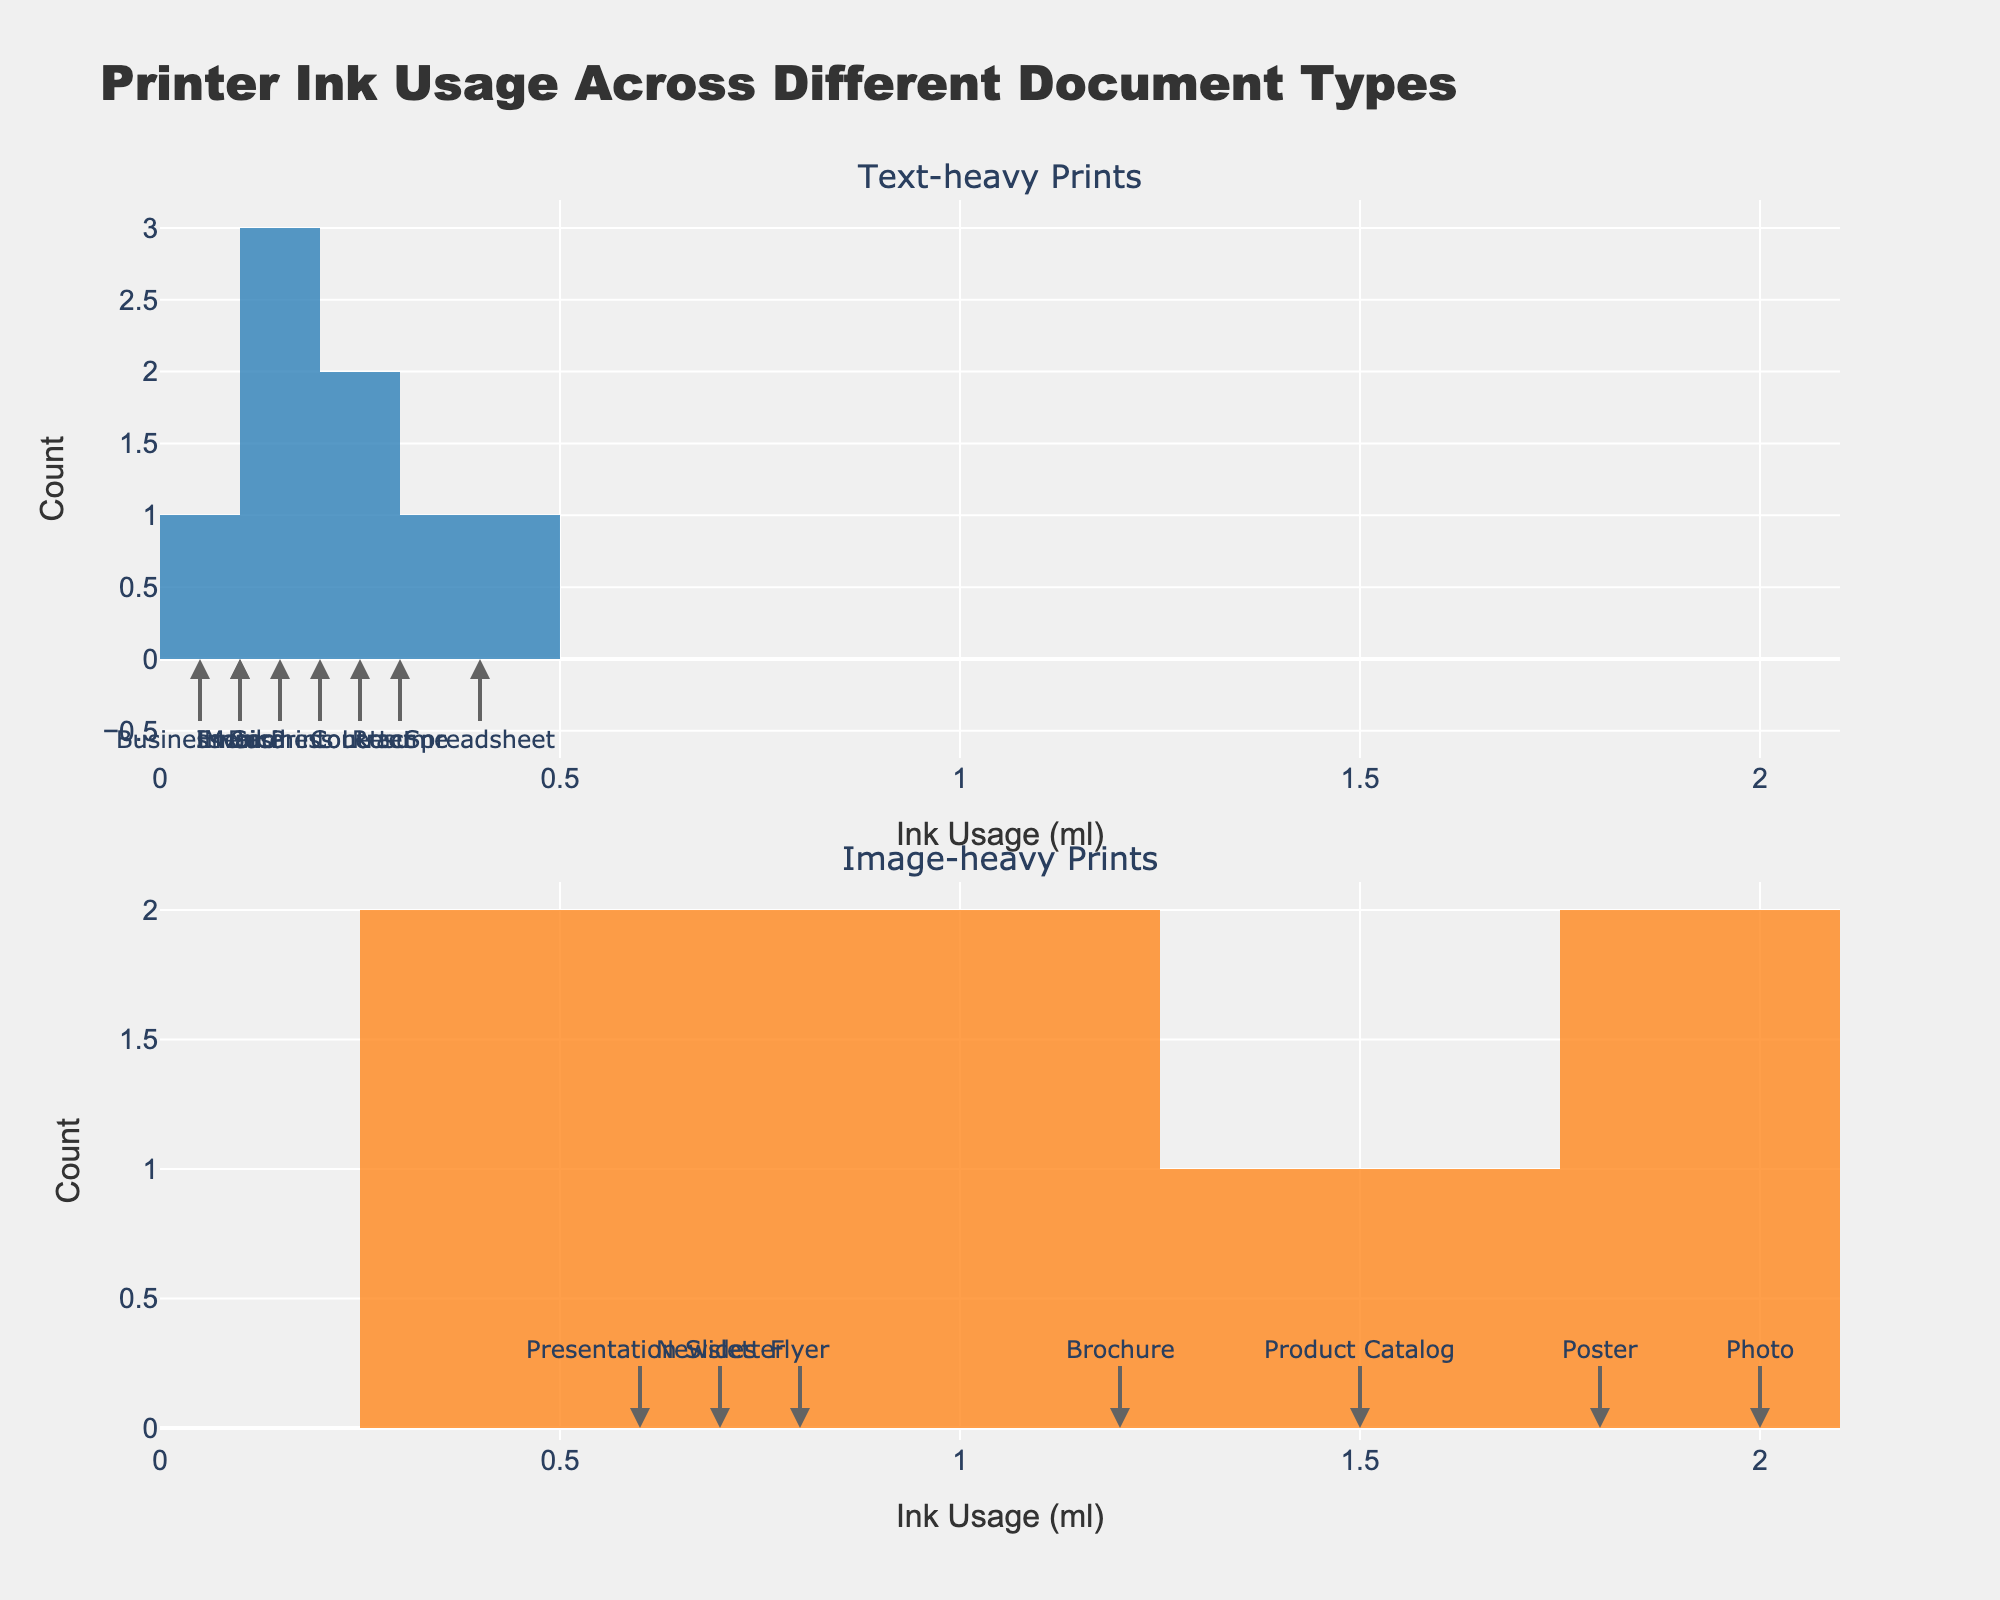What is the title of the figure? The title is displayed at the top center of the figure and provides a quick summary of the plot contents. The title reads "Printer Ink Usage Across Different Document Types".
Answer: Printer Ink Usage Across Different Document Types What does the x-axis represent? The x-axis represents the ink usage measured in milliliters (ml). This is annotated at the bottom of each subplot.
Answer: Ink Usage (ml) What is the color of the histogram bars for text-heavy prints? The bars in the histogram for text-heavy prints are colored blue.
Answer: Blue How many document types had ink usage less than 0.2 ml in text-heavy prints? To find this, observe the histogram in the "Text-heavy Prints" subplot and count the number of bars before the 0.2 ml mark. There are two such document types.
Answer: 2 Which type of print has higher maximum ink usage, text-heavy or image-heavy? By looking at the range of the x-axes of both subplots, it's clear that image-heavy prints reach up to 2.0 ml, whereas text-heavy prints reach only about 0.4 ml. Hence, image-heavy prints have a higher maximum ink usage.
Answer: Image-heavy What is the total number of document types analyzed in both subplots combined? Add the number of document types represented in both subplots. There are 9 text-heavy document types and 6 image-heavy document types. Therefore, the total number is 9 + 6 = 15.
Answer: 15 Which document type had the highest ink usage among image-heavy prints? Look for the highest bar in the "Image-heavy Prints" subplot. The document type labeled at 2.0 ml is "Photo".
Answer: Photo How many text-heavy document types had ink usage between 0.1 ml and 0.3 ml? Count the number of bars within the range of 0.1 ml to 0.3 ml on the "Text-heavy Prints" histogram. There are four such document types.
Answer: 4 Compare the ink usage for "Business Letter" and "Email Printout" in text-heavy prints. Which one uses more ink? Locate the annotations for "Business Letter" and "Email Printout" in the "Text-heavy Prints" histogram. "Business Letter" is at 0.2 ml and "Email Printout" is at 0.15 ml. Therefore, "Business Letter" uses more ink.
Answer: Business Letter In image-heavy prints, which document type had the least ink usage? Identify the document type labeled at the smallest value in the "Image-heavy Prints" histogram. The "Presentation Slides" is at 0.6 ml, which is the smallest among image-heavy prints.
Answer: Presentation Slides 